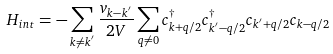Convert formula to latex. <formula><loc_0><loc_0><loc_500><loc_500>H _ { i n t } = - \sum _ { { k } \neq { k } ^ { ^ { \prime } } } \frac { v _ { { k } - { k } ^ { ^ { \prime } } } } { 2 V } \sum _ { { q } \neq 0 } c ^ { \dagger } _ { { k } + { q } / 2 } c ^ { \dagger } _ { { k } ^ { ^ { \prime } } - { q } / 2 } c _ { { k } ^ { ^ { \prime } } + { q } / 2 } c _ { { k } - { q } / 2 }</formula> 